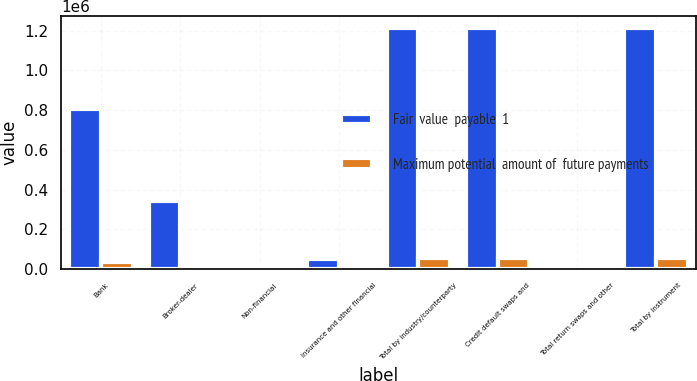Convert chart. <chart><loc_0><loc_0><loc_500><loc_500><stacked_bar_chart><ecel><fcel>Bank<fcel>Broker-dealer<fcel>Non-financial<fcel>Insurance and other financial<fcel>Total by industry/counterparty<fcel>Credit default swaps and<fcel>Total return swaps and other<fcel>Total by instrument<nl><fcel>Fair  value  payable  1<fcel>807484<fcel>340949<fcel>13221<fcel>52366<fcel>1.21405e+06<fcel>1.21321e+06<fcel>845<fcel>1.21405e+06<nl><fcel>Maximum potential  amount of  future payments<fcel>34666<fcel>16309<fcel>262<fcel>7025<fcel>58262<fcel>57987<fcel>275<fcel>58262<nl></chart> 